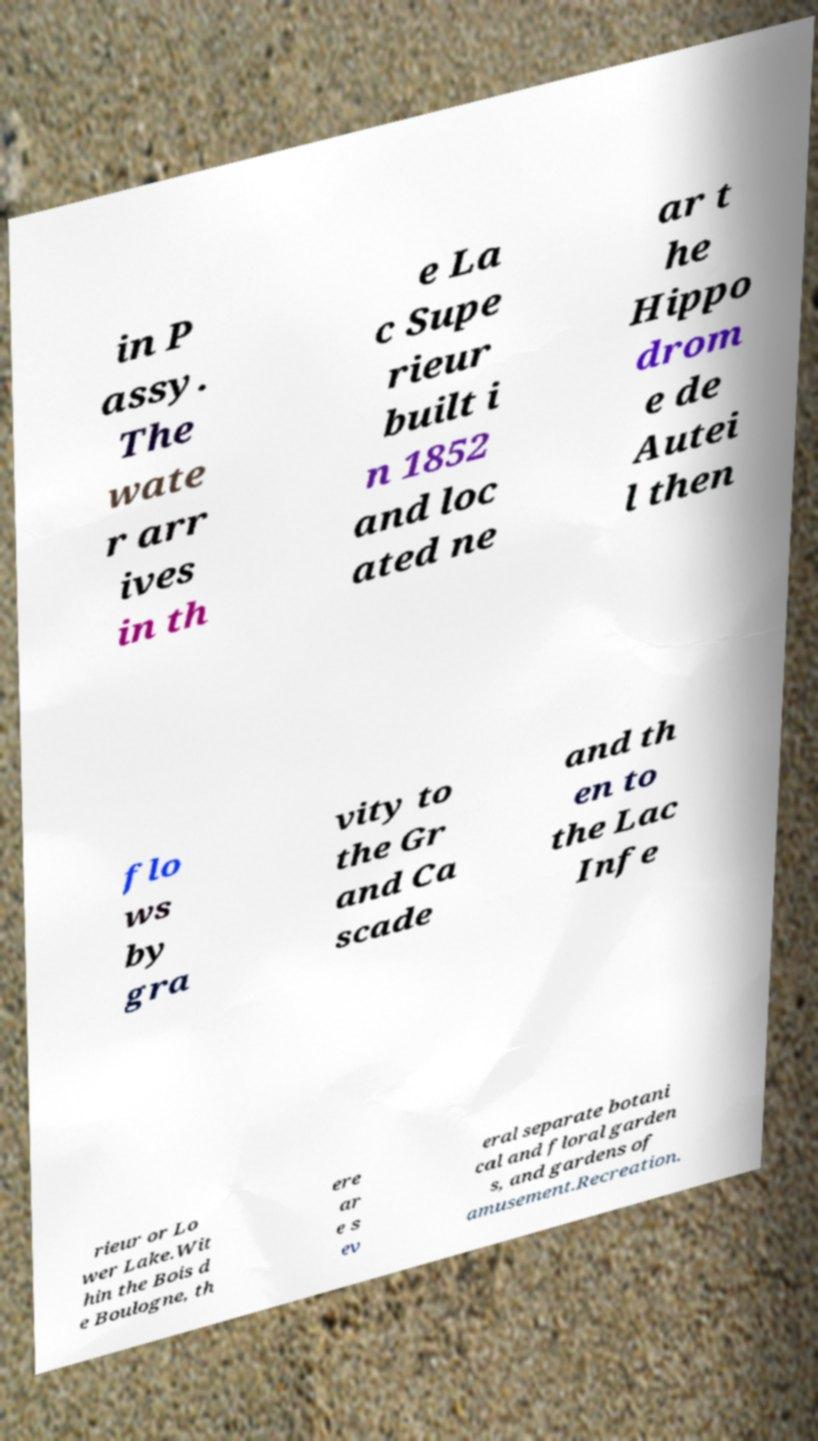Could you extract and type out the text from this image? in P assy. The wate r arr ives in th e La c Supe rieur built i n 1852 and loc ated ne ar t he Hippo drom e de Autei l then flo ws by gra vity to the Gr and Ca scade and th en to the Lac Infe rieur or Lo wer Lake.Wit hin the Bois d e Boulogne, th ere ar e s ev eral separate botani cal and floral garden s, and gardens of amusement.Recreation. 